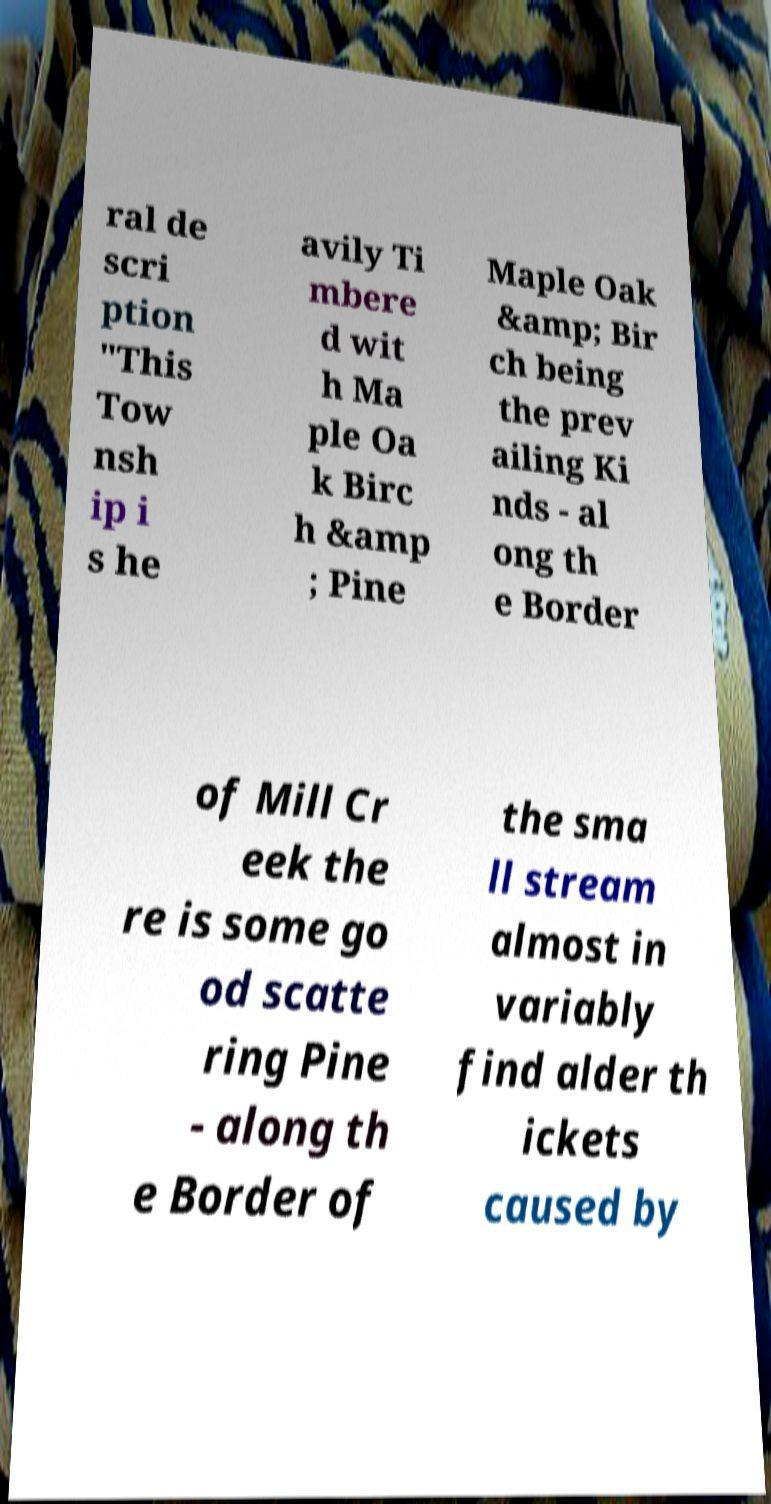Could you extract and type out the text from this image? ral de scri ption "This Tow nsh ip i s he avily Ti mbere d wit h Ma ple Oa k Birc h &amp ; Pine Maple Oak &amp; Bir ch being the prev ailing Ki nds - al ong th e Border of Mill Cr eek the re is some go od scatte ring Pine - along th e Border of the sma ll stream almost in variably find alder th ickets caused by 